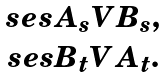<formula> <loc_0><loc_0><loc_500><loc_500>\begin{array} { c } \ s e s { A _ { s } } { V } { B _ { s } } , \\ \ s e s { B _ { t } } { V } { A _ { t } } . \\ \end{array}</formula> 